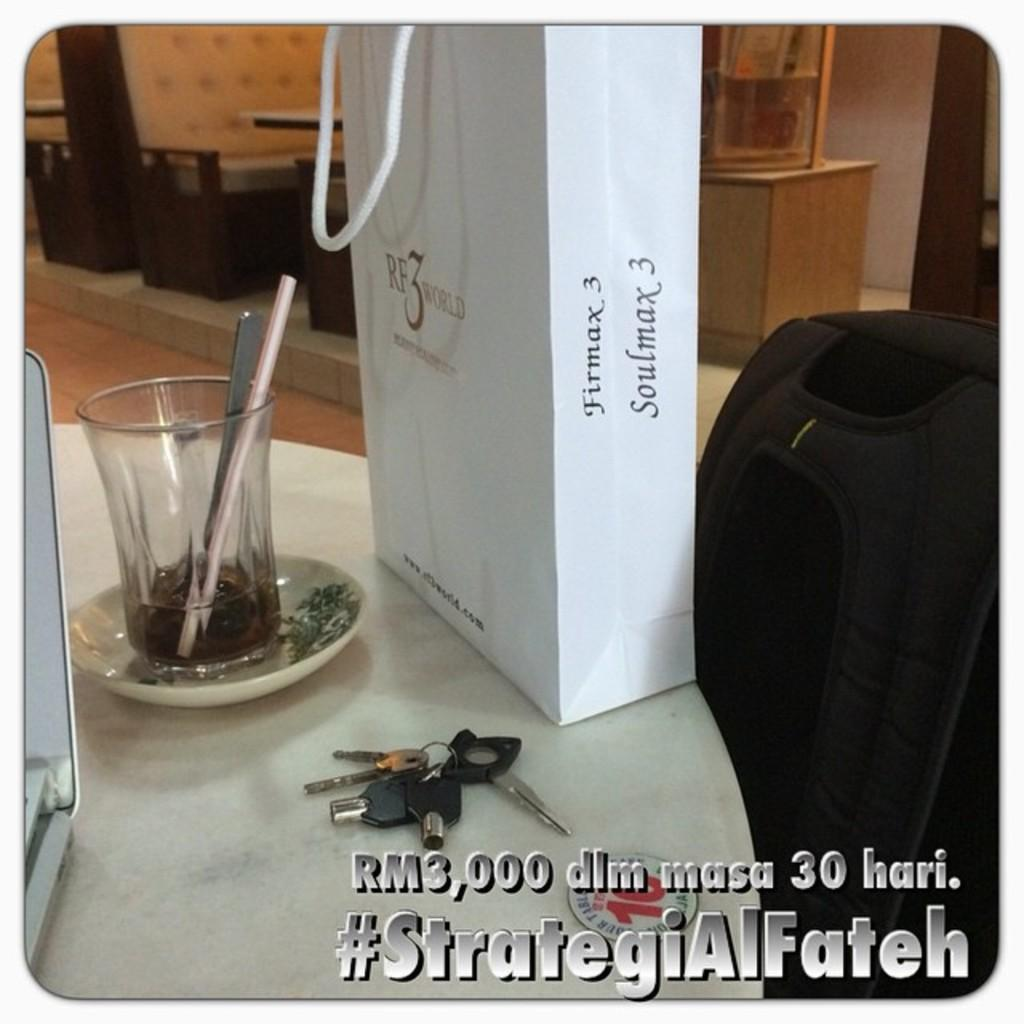Provide a one-sentence caption for the provided image. A gift bag that says Firmax 3  Soulmax 3 on it. 